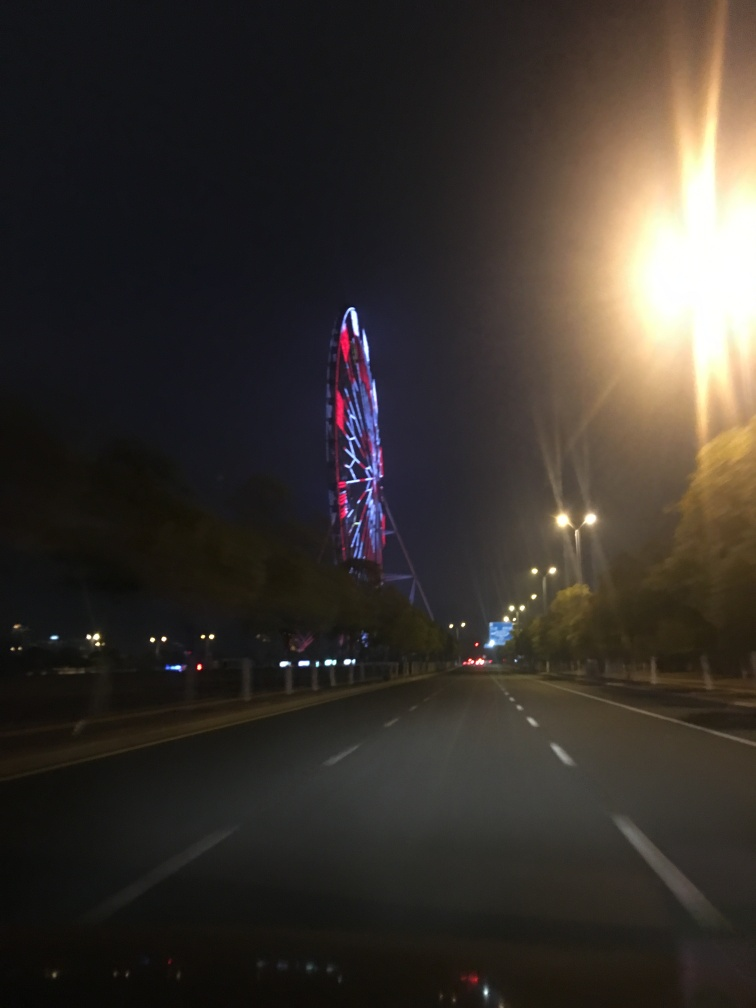Are there any quality issues with this image? Yes, there are several quality issues with the image. Firstly, it's evident that the photo was taken with a low shutter speed resulting in motion blur, particularly observable in the light streaks and lack of sharpness throughout. Additionally, there is noticeable noise in the darker areas, which is a common issue in low-light photography. The image is also not well-framed, with the interesting subject, the Ferris wheel, not centered and the overall composition is unbalanced. Lastly, the streetlights have caused lens flare, contributing to the image's distortion. 